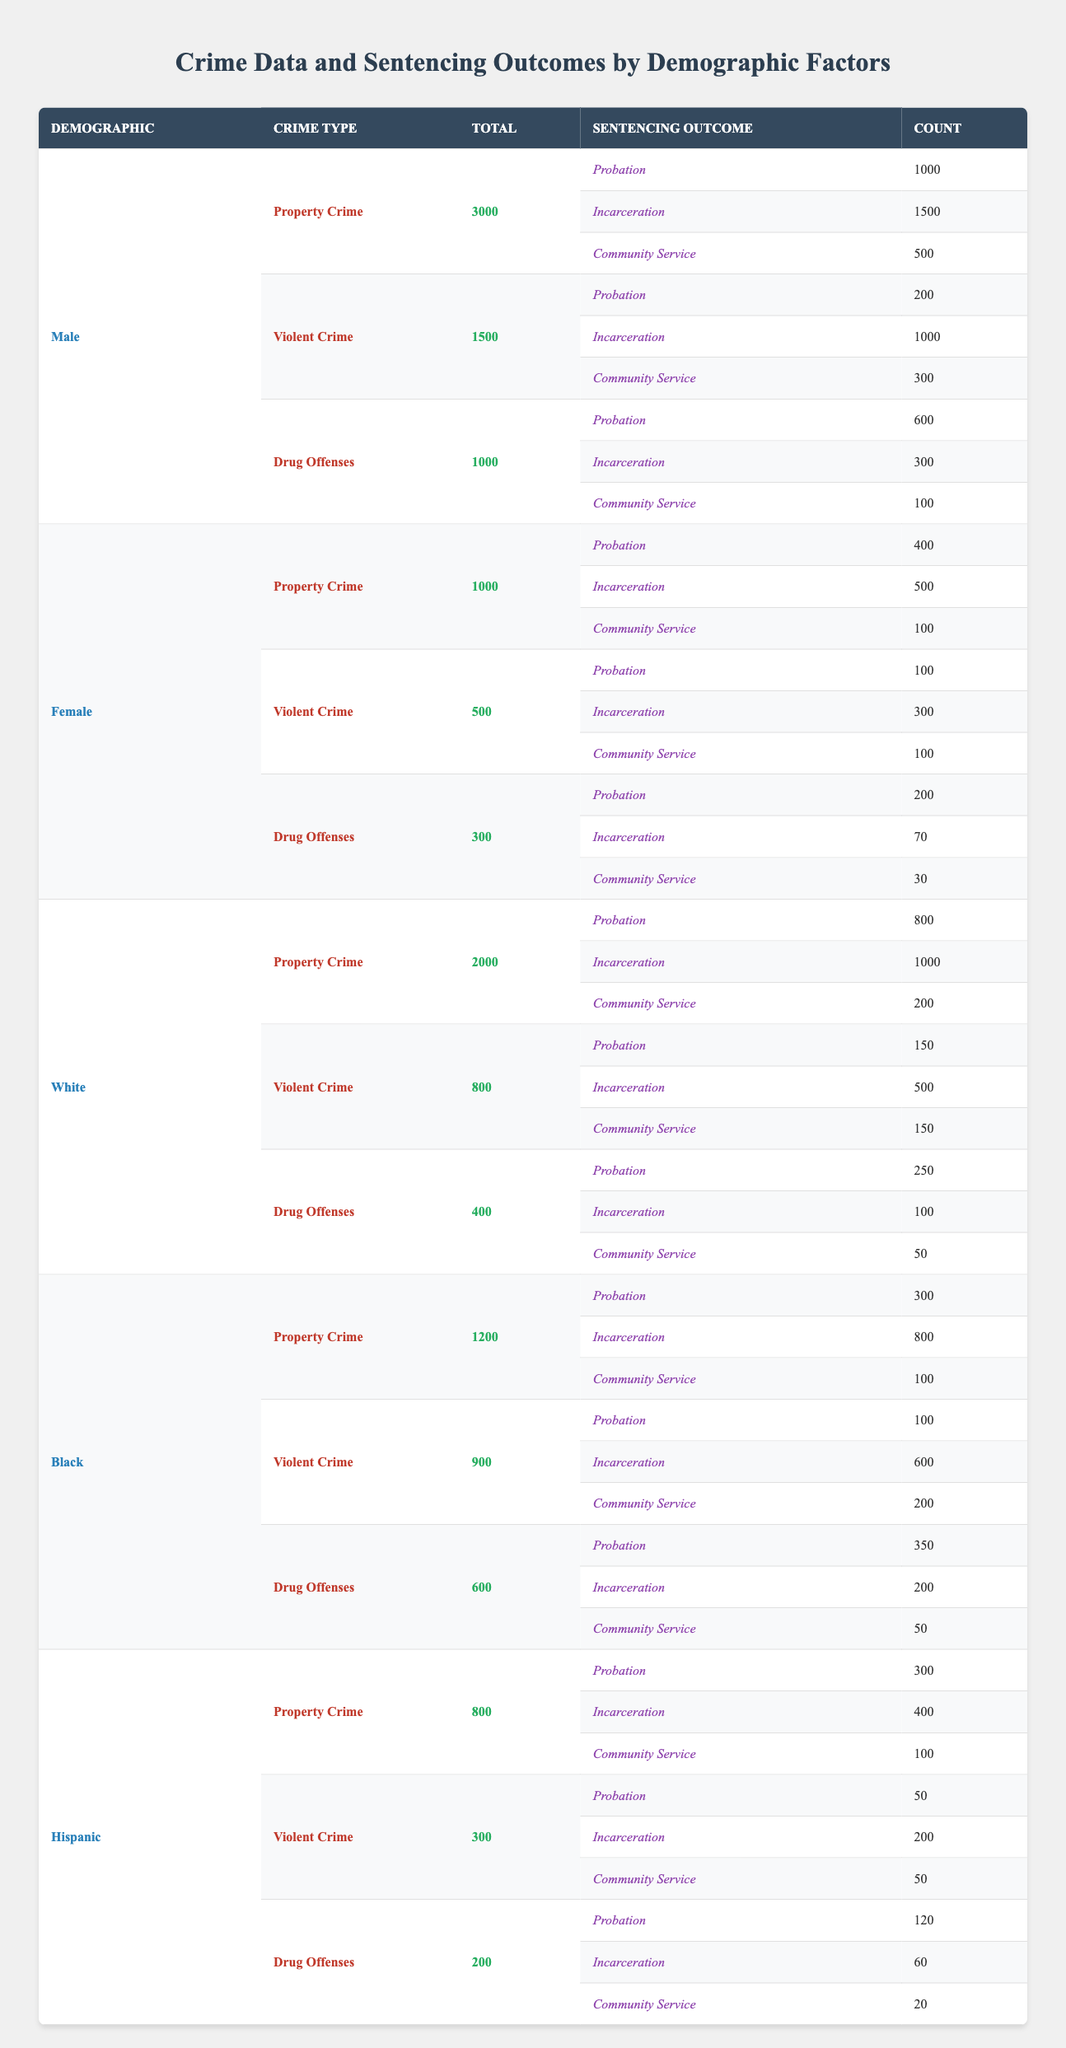What is the total number of crimes committed by White individuals? The total number of crimes committed by White individuals is explicitly stated in the table under the White demographic section. It shows a total of 5000 crimes.
Answer: 5000 How many male offenders received probation for Drug Offenses? The table indicates the sentencing outcomes for male offenders under Drug Offenses. Specifically, it shows that 600 males received probation.
Answer: 600 What is the total number of incarcerations for Black individuals across all crime types? To find this, I need to sum the incarcerations for each crime type (Property Crime: 800 + Violent Crime: 600 + Drug Offenses: 200). The total is 800 + 600 + 200 = 1600.
Answer: 1600 Did females commit more Property Crimes than males? The table lists females committing 1000 Property Crimes compared to males who committed 3000 Property Crimes. Thus, females committed fewer Property Crimes than males.
Answer: No What percentage of the total crimes committed by Hispanic individuals resulted in probation? The total number of crimes committed by Hispanic individuals is 800 (Property Crime) + 300 (Violent Crime) + 200 (Drug Offenses) = 1300. The total number of probations is 300 (Property Crime) + 50 (Violent Crime) + 120 (Drug Offenses) = 470. The percentage is (470 / 1300) * 100 = 36.15%.
Answer: 36.15% How many more males than females were incarcerated for Violent Crimes? Males incarcerated for Violent Crimes total 1000, while females incarcerated for the same are 300. The difference is 1000 - 300 = 700 more males incarcerated.
Answer: 700 What is the total number of Community Service sentencing outcomes among all demographic groups for Drug Offenses? I need to add the Community Service outcomes for each demographic group under Drug Offenses: Males: 100 + Females: 30 + Whites: 50 + Blacks: 50 + Hispanics: 20. The total is 100 + 30 + 50 + 50 + 20 = 250.
Answer: 250 Are females more likely to receive probation than males in Property Crimes? For Property Crimes, males received 1000 probations while females received 400. Since 400 is less than 1000, females are less likely to receive probation than males for Property Crimes.
Answer: No How does the total number of Drug Offenses compare between Black and White individuals? Black individuals committed a total of 600 Drug Offenses while White individuals committed 400. To assess, 600 is greater than 400, meaning Black individuals had more Drug Offenses.
Answer: Black individuals committed more Drug Offenses 